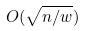<formula> <loc_0><loc_0><loc_500><loc_500>O ( \sqrt { n / w } )</formula> 